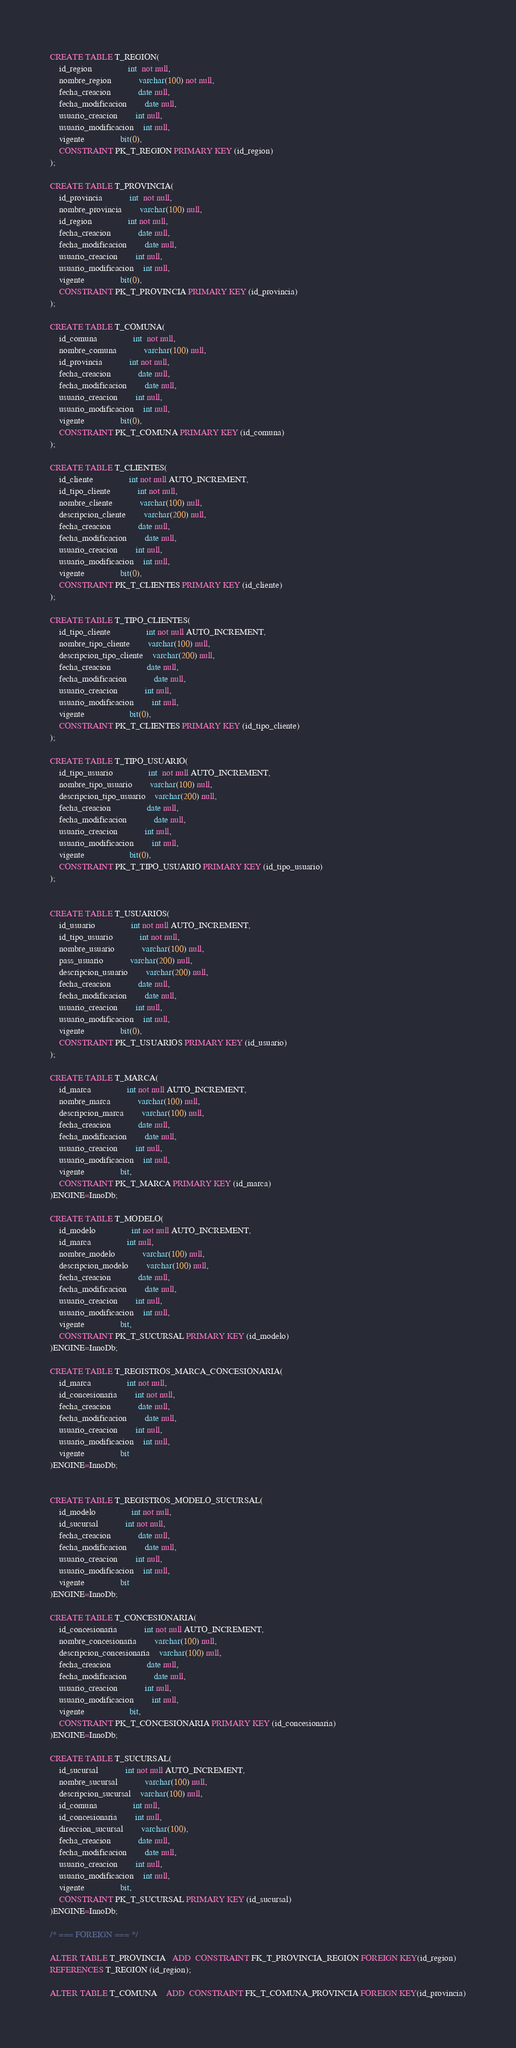Convert code to text. <code><loc_0><loc_0><loc_500><loc_500><_SQL_>CREATE TABLE T_REGION(
	id_region				int  not null,
	nombre_region 			varchar(100) not null,
	fecha_creacion 			date null,
  	fecha_modificacion 		date null,
  	usuario_creacion 		int null,
  	usuario_modificacion 	int null,
 	vigente 				bit(0),
 	CONSTRAINT PK_T_REGION PRIMARY KEY (id_region)
);

CREATE TABLE T_PROVINCIA(
	id_provincia			int  not null,
	nombre_provincia		varchar(100) null,
	id_region				int not null,
	fecha_creacion 			date null,
  	fecha_modificacion 		date null,
  	usuario_creacion 		int null,
  	usuario_modificacion 	int null,
 	vigente 				bit(0),
 	CONSTRAINT PK_T_PROVINCIA PRIMARY KEY (id_provincia)
);

CREATE TABLE T_COMUNA(
	id_comuna				int  not null,
	nombre_comuna 			varchar(100) null,
	id_provincia			int not null,
	fecha_creacion 			date null,
  	fecha_modificacion 		date null,
  	usuario_creacion 		int null,
  	usuario_modificacion 	int null,
 	vigente 				bit(0),
 	CONSTRAINT PK_T_COMUNA PRIMARY KEY (id_comuna)
);

CREATE TABLE T_CLIENTES(
	id_cliente				int not null AUTO_INCREMENT,
	id_tipo_cliente			int not null,
	nombre_cliente 			varchar(100) null,
	descripcion_cliente		varchar(200) null,
	fecha_creacion 			date null,
  	fecha_modificacion 		date null,
  	usuario_creacion 		int null,
  	usuario_modificacion 	int null,
 	vigente 				bit(0),
 	CONSTRAINT PK_T_CLIENTES PRIMARY KEY (id_cliente) 
);

CREATE TABLE T_TIPO_CLIENTES(
	id_tipo_cliente				int not null AUTO_INCREMENT,
	nombre_tipo_cliente 		varchar(100) null,
	descripcion_tipo_cliente	varchar(200) null,
	fecha_creacion 				date null,
  	fecha_modificacion 			date null,
  	usuario_creacion 			int null,
  	usuario_modificacion 		int null,
 	vigente 					bit(0),
 	CONSTRAINT PK_T_CLIENTES PRIMARY KEY (id_tipo_cliente) 
);

CREATE TABLE T_TIPO_USUARIO(
	id_tipo_usuario				int  not null AUTO_INCREMENT,
	nombre_tipo_usuario 		varchar(100) null,
	descripcion_tipo_usuario	varchar(200) null,
	fecha_creacion 				date null,
  	fecha_modificacion 			date null,
  	usuario_creacion 			int null,
  	usuario_modificacion 		int null,
 	vigente 					bit(0),
 	CONSTRAINT PK_T_TIPO_USUARIO PRIMARY KEY (id_tipo_usuario) 
);


CREATE TABLE T_USUARIOS(
	id_usuario				int not null AUTO_INCREMENT,
	id_tipo_usuario			int not null,
	nombre_usuario 			varchar(100) null,
	pass_usuario			varchar(200) null,
	descripcion_usuario		varchar(200) null,
	fecha_creacion 			date null,
  	fecha_modificacion 		date null,
  	usuario_creacion 		int null,
  	usuario_modificacion 	int null,
 	vigente 				bit(0),
 	CONSTRAINT PK_T_USUARIOS PRIMARY KEY (id_usuario) 
);

CREATE TABLE T_MARCA(
	id_marca				int not null AUTO_INCREMENT,
	nombre_marca 			varchar(100) null,
	descripcion_marca 		varchar(100) null,
	fecha_creacion 			date null,
  	fecha_modificacion 		date null,
  	usuario_creacion 		int null,
  	usuario_modificacion 	int null,
 	vigente 				bit,
 	CONSTRAINT PK_T_MARCA PRIMARY KEY (id_marca)
)ENGINE=InnoDb;

CREATE TABLE T_MODELO(
	id_modelo				int not null AUTO_INCREMENT,
    id_marca				int null,
	nombre_modelo			varchar(100) null,
	descripcion_modelo		varchar(100) null,
	fecha_creacion 			date null,
  	fecha_modificacion 		date null,
  	usuario_creacion 		int null,
  	usuario_modificacion 	int null,
 	vigente 				bit,
 	CONSTRAINT PK_T_SUCURSAL PRIMARY KEY (id_modelo)
)ENGINE=InnoDb;

CREATE TABLE T_REGISTROS_MARCA_CONCESIONARIA(
	id_marca 				int not null,
	id_concesionaria 		int not null,
	fecha_creacion 			date null,
  	fecha_modificacion 		date null,
  	usuario_creacion 		int null,
  	usuario_modificacion 	int null,
 	vigente 				bit
)ENGINE=InnoDb;


CREATE TABLE T_REGISTROS_MODELO_SUCURSAL(
	id_modelo 				int not null,
	id_sucursal 			int not null,
	fecha_creacion 			date null,
  	fecha_modificacion 		date null,
  	usuario_creacion 		int null,
  	usuario_modificacion 	int null,
 	vigente 				bit
)ENGINE=InnoDb;

CREATE TABLE T_CONCESIONARIA(
	id_concesionaria			int not null AUTO_INCREMENT,
	nombre_concesionaria		varchar(100) null,
	descripcion_concesionaria 	varchar(100) null,
	fecha_creacion 				date null,
  	fecha_modificacion 			date null,
  	usuario_creacion 			int null,
  	usuario_modificacion 		int null,
 	vigente 					bit,
 	CONSTRAINT PK_T_CONCESIONARIA PRIMARY KEY (id_concesionaria)
)ENGINE=InnoDb;

CREATE TABLE T_SUCURSAL(
	id_sucursal 			int not null AUTO_INCREMENT,
	nombre_sucursal			varchar(100) null,
	descripcion_sucursal 	varchar(100) null,
	id_comuna				int null,
	id_concesionaria		int null,
	direccion_sucursal		varchar(100),
	fecha_creacion 			date null,
  	fecha_modificacion 		date null,
  	usuario_creacion 		int null,
  	usuario_modificacion 	int null,
 	vigente 				bit,
 	CONSTRAINT PK_T_SUCURSAL PRIMARY KEY (id_sucursal)
)ENGINE=InnoDb;

/* === FOREIGN === */

ALTER TABLE T_PROVINCIA   ADD  CONSTRAINT FK_T_PROVINCIA_REGION FOREIGN KEY(id_region)
REFERENCES T_REGION (id_region);

ALTER TABLE T_COMUNA    ADD  CONSTRAINT FK_T_COMUNA_PROVINCIA FOREIGN KEY(id_provincia)</code> 